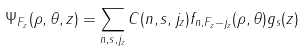Convert formula to latex. <formula><loc_0><loc_0><loc_500><loc_500>\Psi _ { F _ { z } } ( \rho , \theta , z ) = \sum _ { n , s , j _ { z } } C ( n , s , j _ { z } ) f _ { n , F _ { z } - j _ { z } } ( \rho , \theta ) g _ { s } ( z )</formula> 